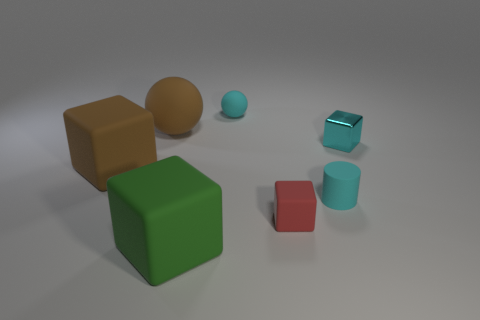There is a small sphere on the right side of the block that is left of the green object; what is its color? cyan 